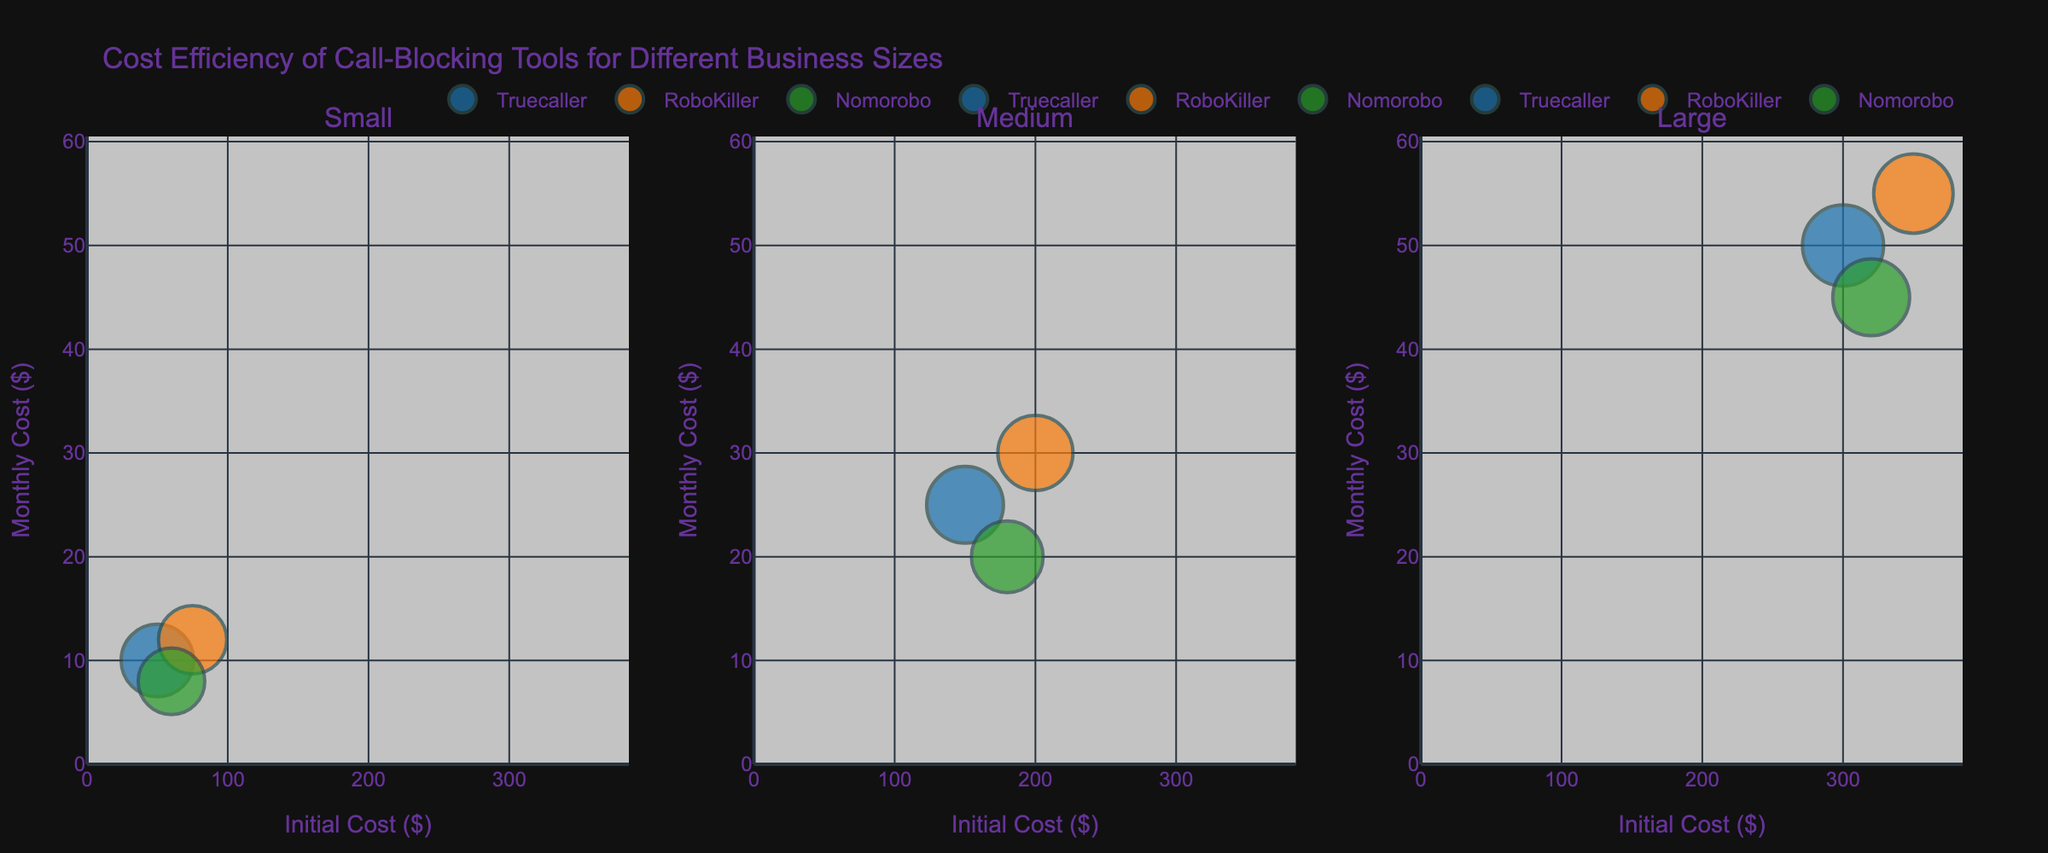What's the title of the figure? The figure title is displayed at the top of the visualization, indicating the main purpose and scope of the plot. In this case, it shows "Cost Efficiency of Call-Blocking Tools for Different Business Sizes".
Answer: Cost Efficiency of Call-Blocking Tools for Different Business Sizes Which call-blocking tool has the highest effectiveness for Medium-size businesses? By identifying the subplot titled 'Medium' and comparing the bubble sizes (which represent effectiveness), we find Truecaller has the largest bubble, indicating the highest effectiveness.
Answer: Truecaller What is the range of the Initial Costs for the call-blocking tools? The x-axis represents the Initial Cost, with labels indicating the range. By checking the extremes of the x-axis, we see costs go from $0 to approximately $385 due to the 10% buffer.
Answer: 0 to 385 Which business size has the highest monthly cost for using RoboKiller? We need to look at the subplots for Small, Medium, and Large business sizes and compare the y-axis values (Monthly Cost) for RoboKiller bubbles. The Large business size has the highest monthly cost.
Answer: Large How does the effectiveness of Truecaller compare to Nomorobo for Large businesses? Comparing the sizes of the bubbles for Truecaller and Nomorobo in the 'Large' subplot, Truecaller's bubble is noticeably larger, indicating higher effectiveness.
Answer: Truecaller has higher effectiveness Which tool offers the highest savings for Small businesses? By examining the mouse-hover text of bubbles in the 'Small' subplot, we can identify the savings. The bubble for RoboKiller, quoting $250 in savings, is the highest.
Answer: RoboKiller What is the approximate initial cost difference between the most expensive and least expensive tools for Medium businesses? Identifying the highest and lowest points on the x-axis in the 'Medium' subplot, RoboKiller ($200) and Truecaller ($150), we calculate the difference as $200 - $150.
Answer: $50 What is the maximum number of users for any call-blocking tool shown? Checking all bubbles in terms of hover text, the largest number of users quoted is 150 for Truecaller in the Large business category.
Answer: 150 Which call-blocking tool for Small businesses has the lowest monthly cost and what is it? Within the 'Small' subplot, compare the y-axis values (Monthly Cost) for each bubble, identifying Nomorobo as having the lowest monthly cost of $8.
Answer: Nomorobo, $8 